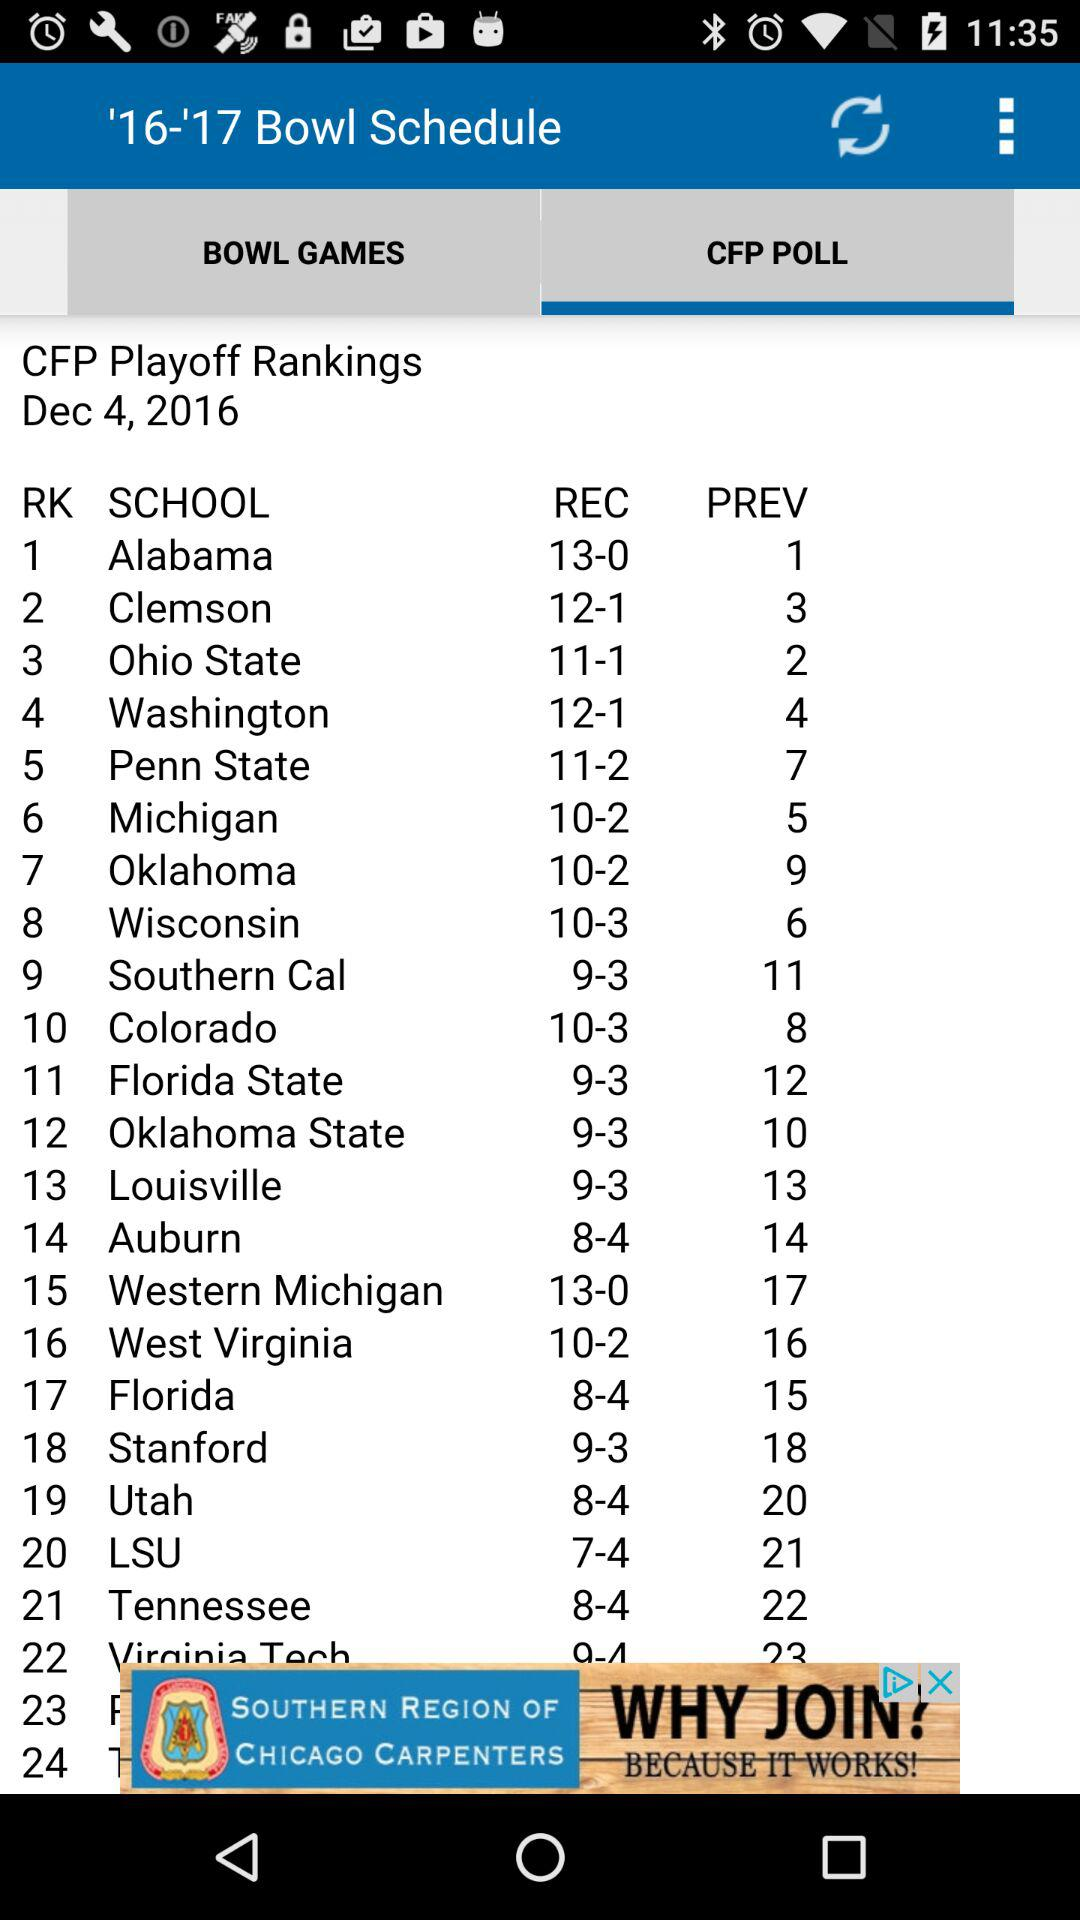Which tab is selected? The selected tab is "CFP POLL". 